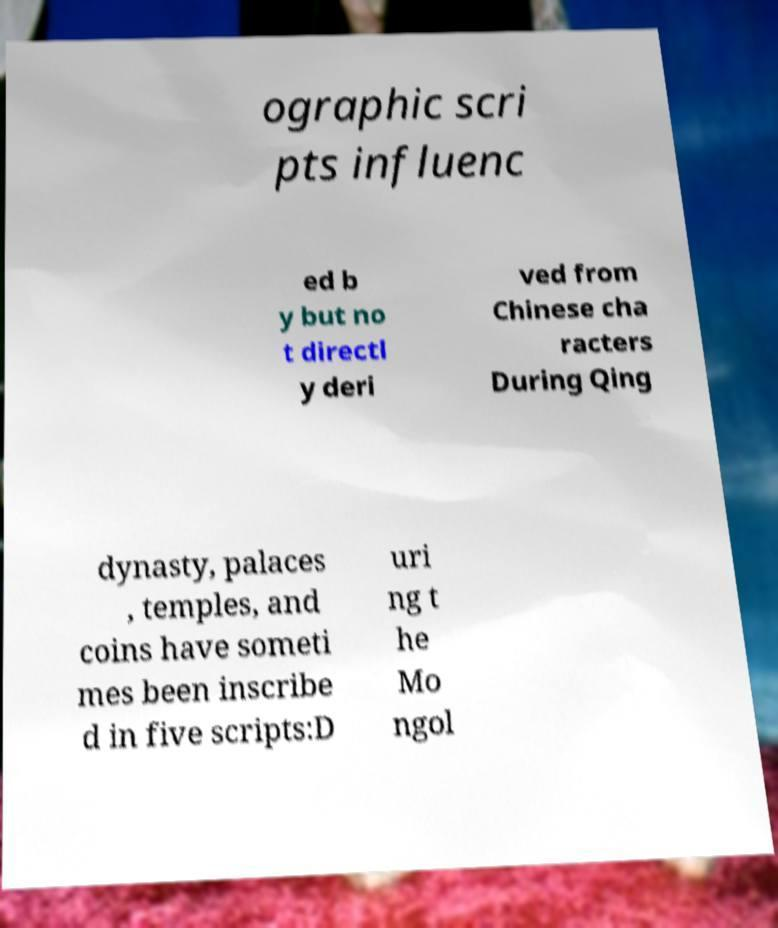There's text embedded in this image that I need extracted. Can you transcribe it verbatim? ographic scri pts influenc ed b y but no t directl y deri ved from Chinese cha racters During Qing dynasty, palaces , temples, and coins have someti mes been inscribe d in five scripts:D uri ng t he Mo ngol 